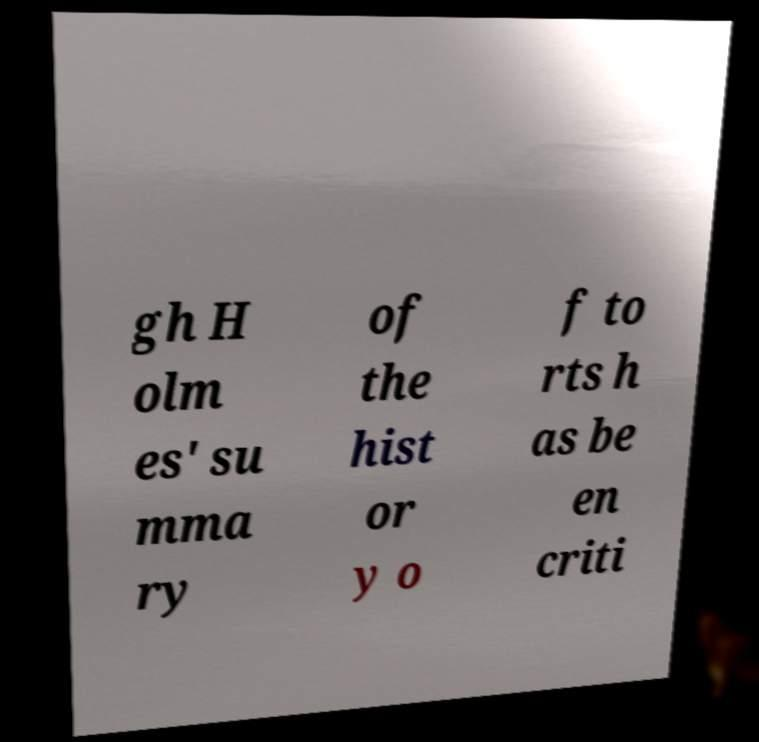What messages or text are displayed in this image? I need them in a readable, typed format. gh H olm es' su mma ry of the hist or y o f to rts h as be en criti 